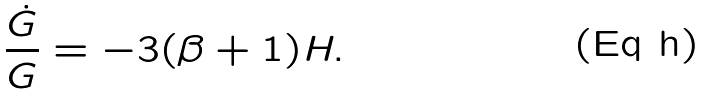<formula> <loc_0><loc_0><loc_500><loc_500>\frac { \dot { G } } { G } = - 3 ( \beta + 1 ) H .</formula> 